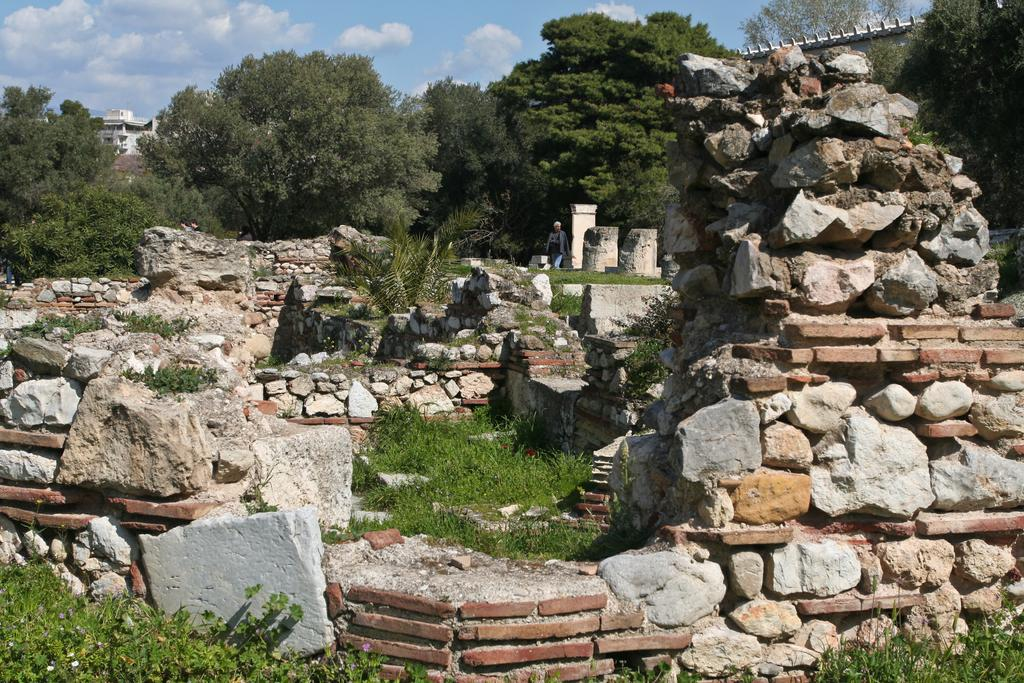What type of materials can be seen in the image? There are stones and bricks in the image. What natural elements are present in the image? There is: There is grass, trees, and the sky visible in the image. What man-made structures can be seen in the image? There are buildings in the image. What is the weather like in the image? The sky is cloudy and pale blue, suggesting a cloudy day. What is the person in the image doing? The person is walking in the image. What is the person wearing? The person is wearing clothes. What type of advertisement can be seen on the meat in the image? There is no meat or advertisement present in the image. Can you describe the kiss between the two people in the image? There are no people kissing in the image; only a person walking is visible. 